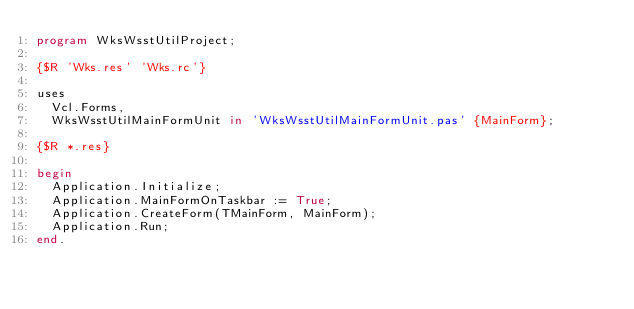<code> <loc_0><loc_0><loc_500><loc_500><_Pascal_>program WksWsstUtilProject;

{$R 'Wks.res' 'Wks.rc'}

uses
  Vcl.Forms,
  WksWsstUtilMainFormUnit in 'WksWsstUtilMainFormUnit.pas' {MainForm};

{$R *.res}

begin
  Application.Initialize;
  Application.MainFormOnTaskbar := True;
  Application.CreateForm(TMainForm, MainForm);
  Application.Run;
end.
</code> 